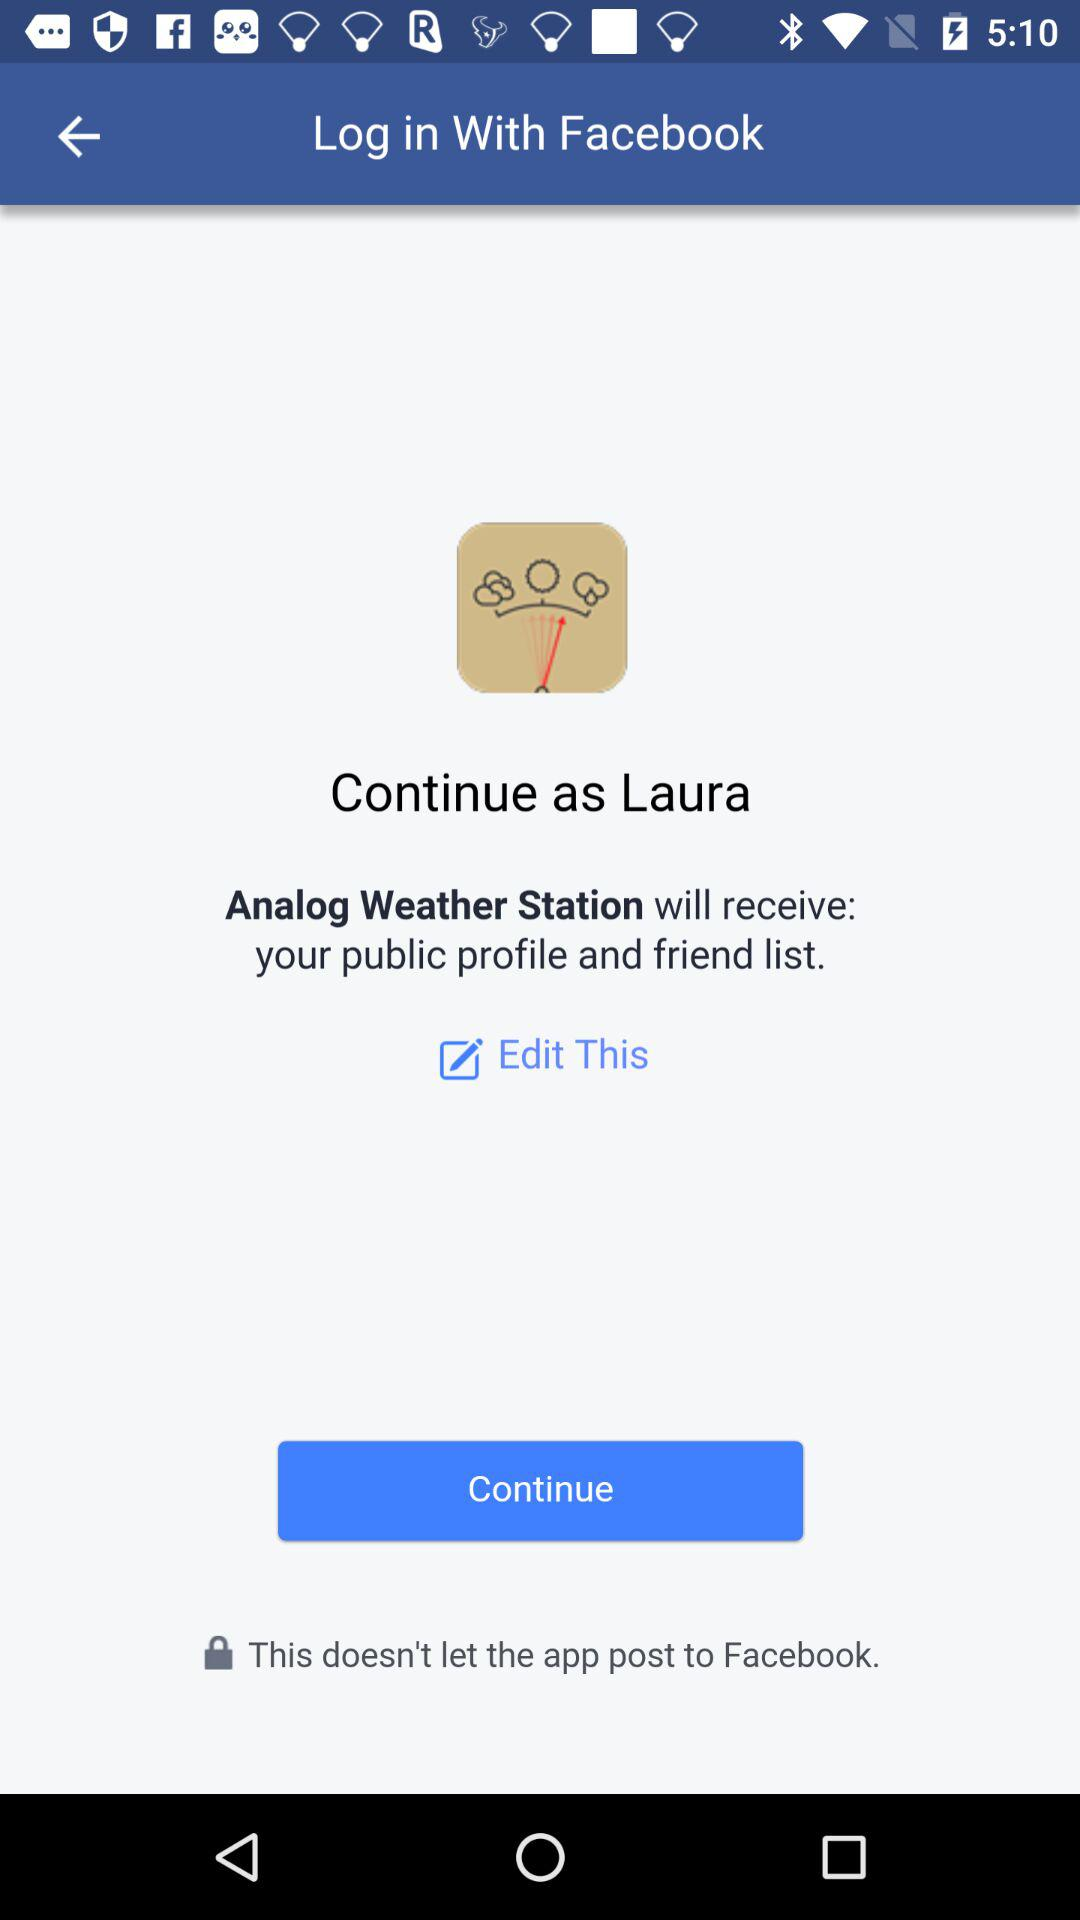What is the name of the user? The name of the user is Laura. 